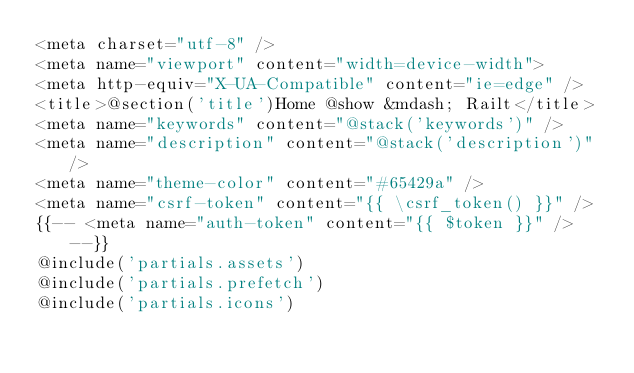Convert code to text. <code><loc_0><loc_0><loc_500><loc_500><_PHP_><meta charset="utf-8" />
<meta name="viewport" content="width=device-width">
<meta http-equiv="X-UA-Compatible" content="ie=edge" />
<title>@section('title')Home @show &mdash; Railt</title>
<meta name="keywords" content="@stack('keywords')" />
<meta name="description" content="@stack('description')" />
<meta name="theme-color" content="#65429a" />
<meta name="csrf-token" content="{{ \csrf_token() }}" />
{{-- <meta name="auth-token" content="{{ $token }}" /> --}}
@include('partials.assets')
@include('partials.prefetch')
@include('partials.icons')
</code> 